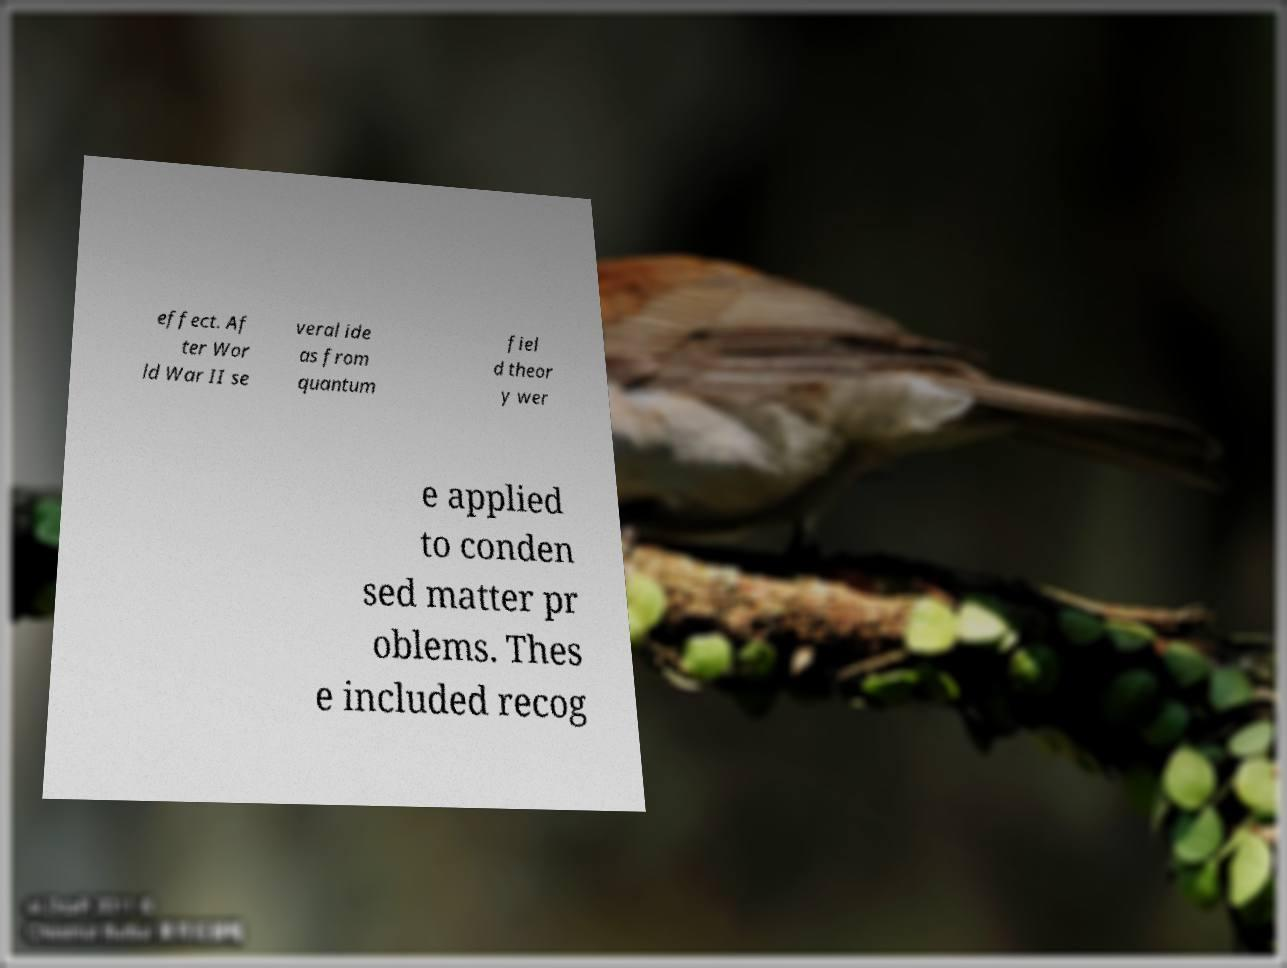There's text embedded in this image that I need extracted. Can you transcribe it verbatim? effect. Af ter Wor ld War II se veral ide as from quantum fiel d theor y wer e applied to conden sed matter pr oblems. Thes e included recog 